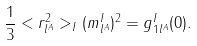<formula> <loc_0><loc_0><loc_500><loc_500>\frac { 1 } { 3 } < r ^ { 2 } _ { l ^ { A } } > _ { I } ( m _ { l ^ { A } } ^ { I } ) ^ { 2 } = g _ { 1 l ^ { A } } ^ { I } ( 0 ) .</formula> 